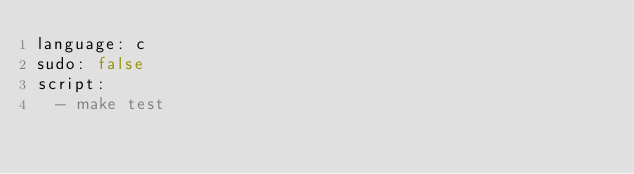Convert code to text. <code><loc_0><loc_0><loc_500><loc_500><_YAML_>language: c
sudo: false
script:
  - make test
</code> 